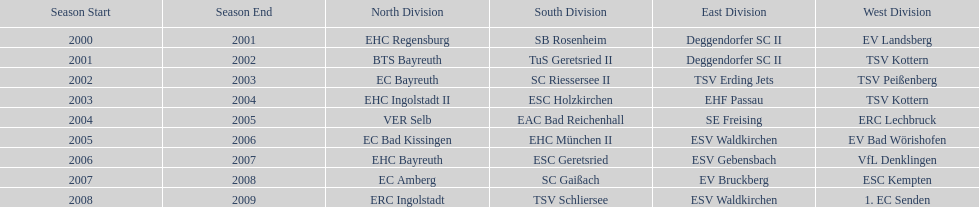Parse the table in full. {'header': ['Season Start', 'Season End', 'North Division', 'South Division', 'East Division', 'West Division'], 'rows': [['2000', '2001', 'EHC Regensburg', 'SB Rosenheim', 'Deggendorfer SC II', 'EV Landsberg'], ['2001', '2002', 'BTS Bayreuth', 'TuS Geretsried II', 'Deggendorfer SC II', 'TSV Kottern'], ['2002', '2003', 'EC Bayreuth', 'SC Riessersee II', 'TSV Erding Jets', 'TSV Peißenberg'], ['2003', '2004', 'EHC Ingolstadt II', 'ESC Holzkirchen', 'EHF Passau', 'TSV Kottern'], ['2004', '2005', 'VER Selb', 'EAC Bad Reichenhall', 'SE Freising', 'ERC Lechbruck'], ['2005', '2006', 'EC Bad Kissingen', 'EHC München II', 'ESV Waldkirchen', 'EV Bad Wörishofen'], ['2006', '2007', 'EHC Bayreuth', 'ESC Geretsried', 'ESV Gebensbach', 'VfL Denklingen'], ['2007', '2008', 'EC Amberg', 'SC Gaißach', 'EV Bruckberg', 'ESC Kempten'], ['2008', '2009', 'ERC Ingolstadt', 'TSV Schliersee', 'ESV Waldkirchen', '1. EC Senden']]} Starting with the 2007 - 08 season, does ecs kempten appear in any of the previous years? No. 